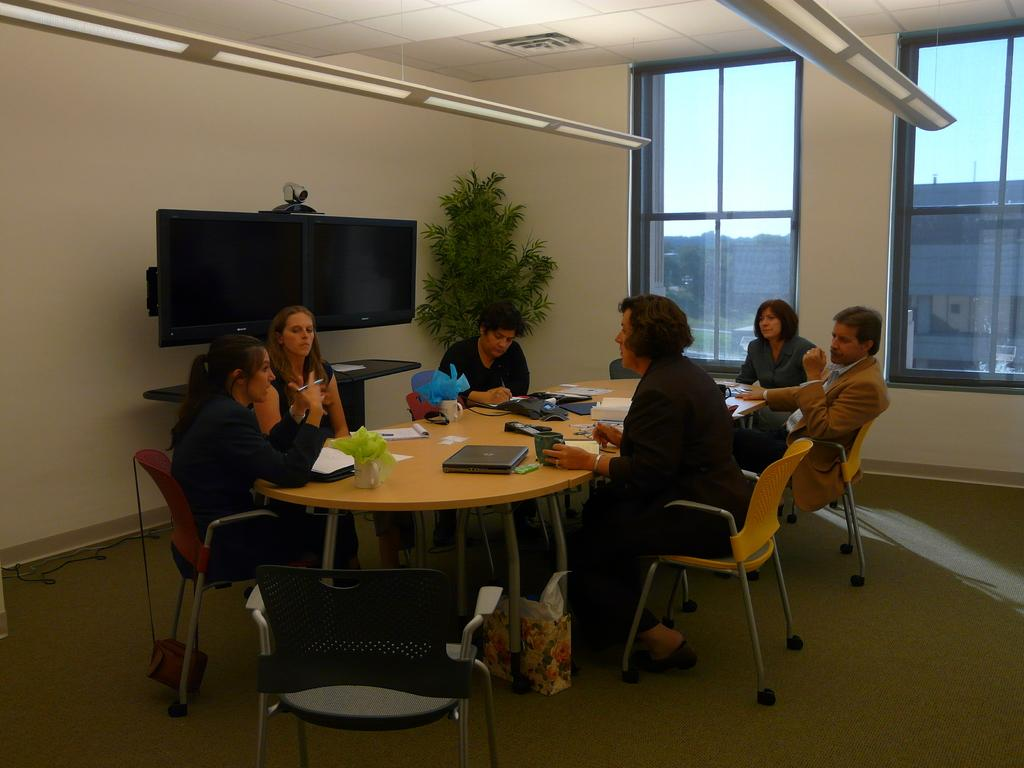What are the people in the image doing? People are seated on chairs around a table in the image. What electronic device is on the table? There is a laptop on the table. What type of container is on the table? There is a cup on the table. What type of writing material is on the table? There is paper on the table. What type of reading material is on the table? There is a book on the table. What is behind the people in the image? There is a TV and a plant behind the people in the image. What can be seen on the right side of the image? There are glass windows on the right side. Where is the drain located in the image? There is no drain present in the image. What type of paper is being used to write on in the image? The image does not show anyone writing on paper, so it cannot be determined what type of paper is being used. 